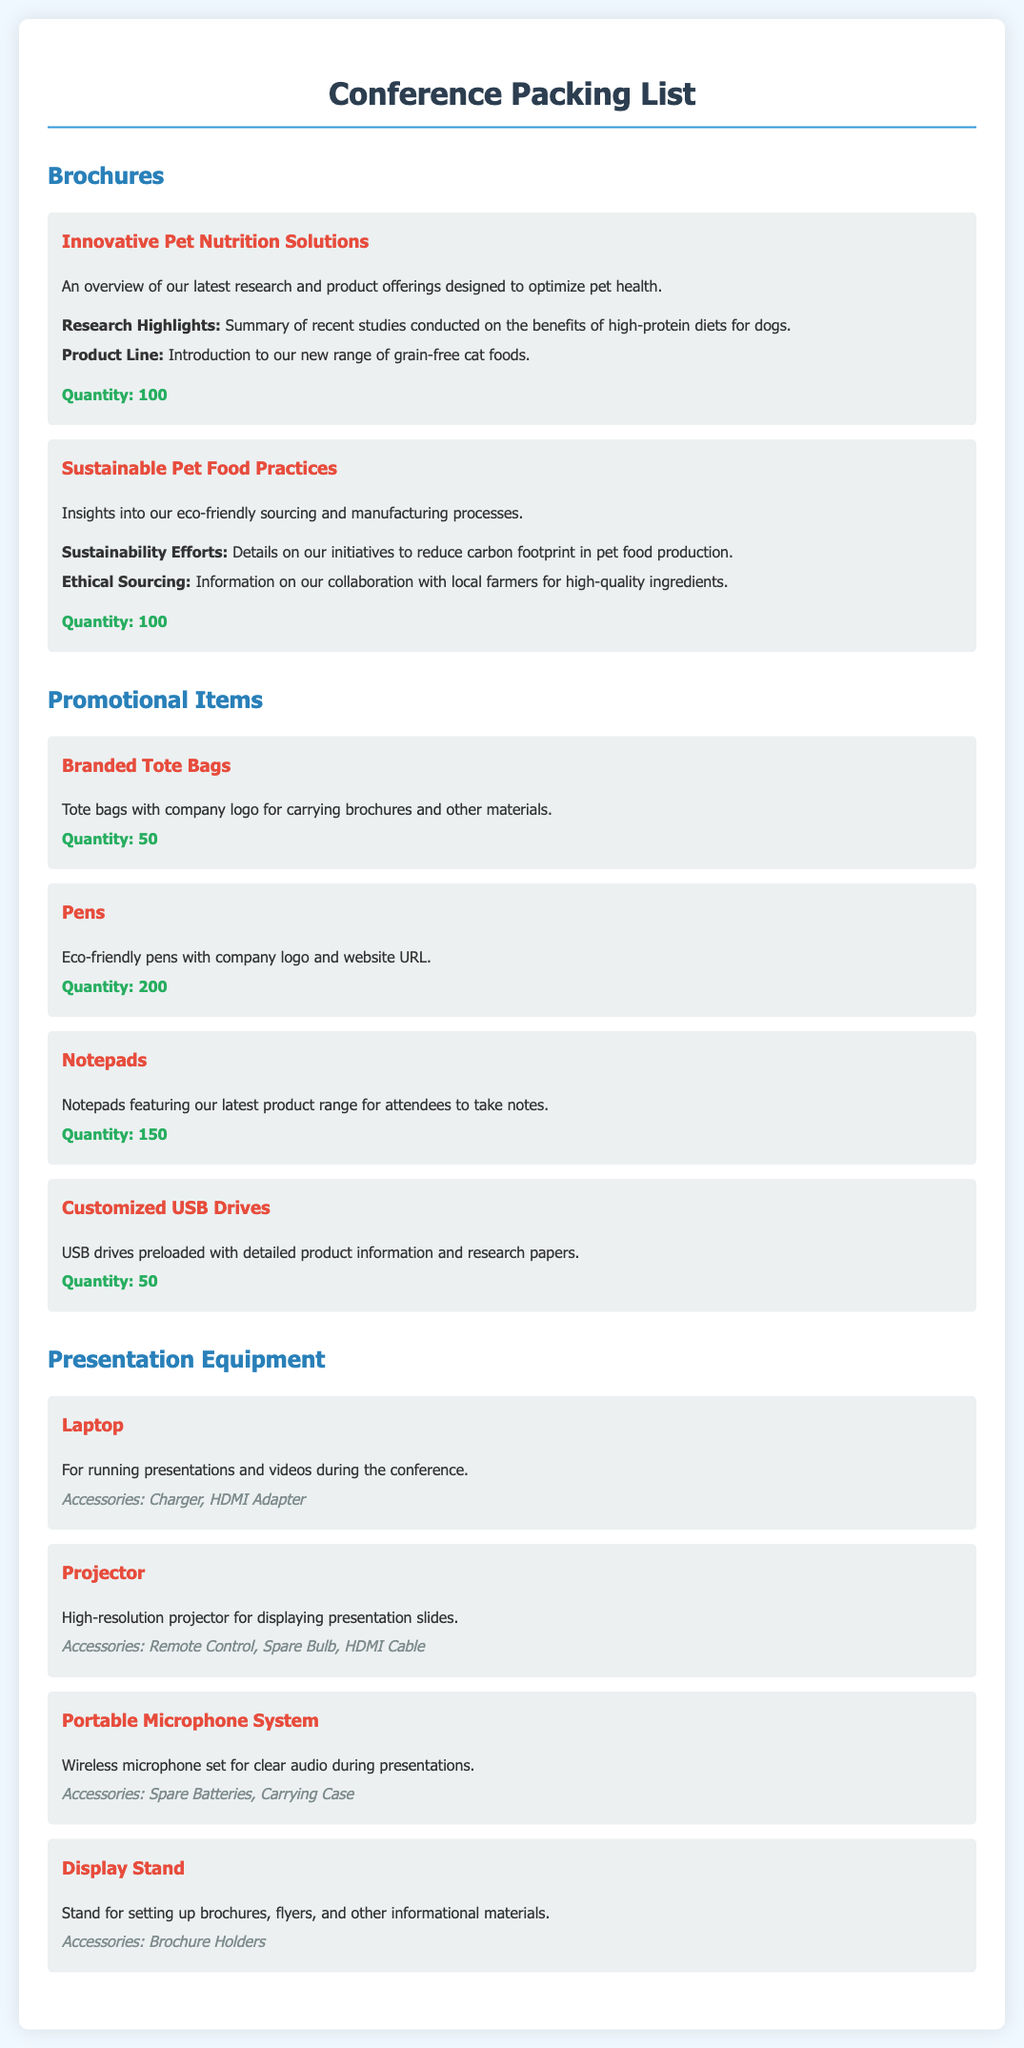What is the title of the first brochure? The title of the first brochure is mentioned in the section about brochures, which is "Innovative Pet Nutrition Solutions."
Answer: Innovative Pet Nutrition Solutions How many promotional items are listed? The document provides a total count of promotional items listed in the section titled "Promotional Items." There are four items listed: Branded Tote Bags, Pens, Notepads, and Customized USB Drives.
Answer: 4 What is the quantity of eco-friendly pens? The quantity of eco-friendly pens is specified in the "Promotional Items" section under "Pens."
Answer: 200 Which presentation equipment has accessories? The document describes several pieces of presentation equipment, and all of them have accessories listed. The first one with accessories mentioned is the "Laptop," followed by others.
Answer: Laptop, Projector, Portable Microphone System, Display Stand What information is provided under "Sustainable Pet Food Practices"? An overview of information is given under this brochure, including insights into eco-friendly sourcing and manufacturing processes.
Answer: Insights into our eco-friendly sourcing and manufacturing processes How many notepads are being brought? The document specifies the quantity of notepads listed under "Promotional Items."
Answer: 150 What are the accessories for the projector? The projector is listed with its specific accessories in the "Presentation Equipment" section, which includes Remote Control, Spare Bulb, and HDMI Cable.
Answer: Remote Control, Spare Bulb, HDMI Cable What is the purpose of the display stand? The purpose of the display stand is described in the "Presentation Equipment" section, indicating its use for setting up brochures and flyers.
Answer: Setting up brochures, flyers, and other informational materials 